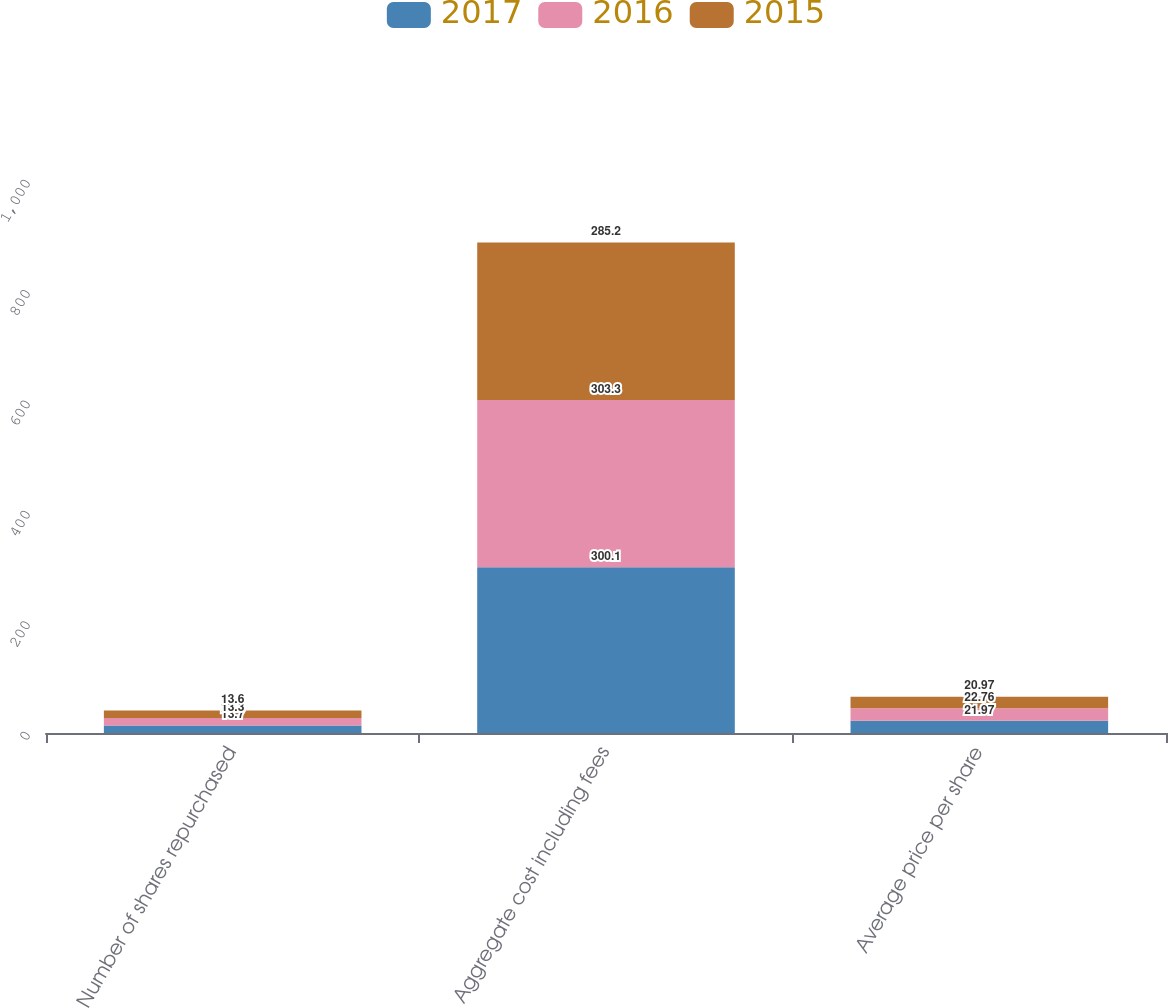<chart> <loc_0><loc_0><loc_500><loc_500><stacked_bar_chart><ecel><fcel>Number of shares repurchased<fcel>Aggregate cost including fees<fcel>Average price per share<nl><fcel>2017<fcel>13.7<fcel>300.1<fcel>21.97<nl><fcel>2016<fcel>13.3<fcel>303.3<fcel>22.76<nl><fcel>2015<fcel>13.6<fcel>285.2<fcel>20.97<nl></chart> 